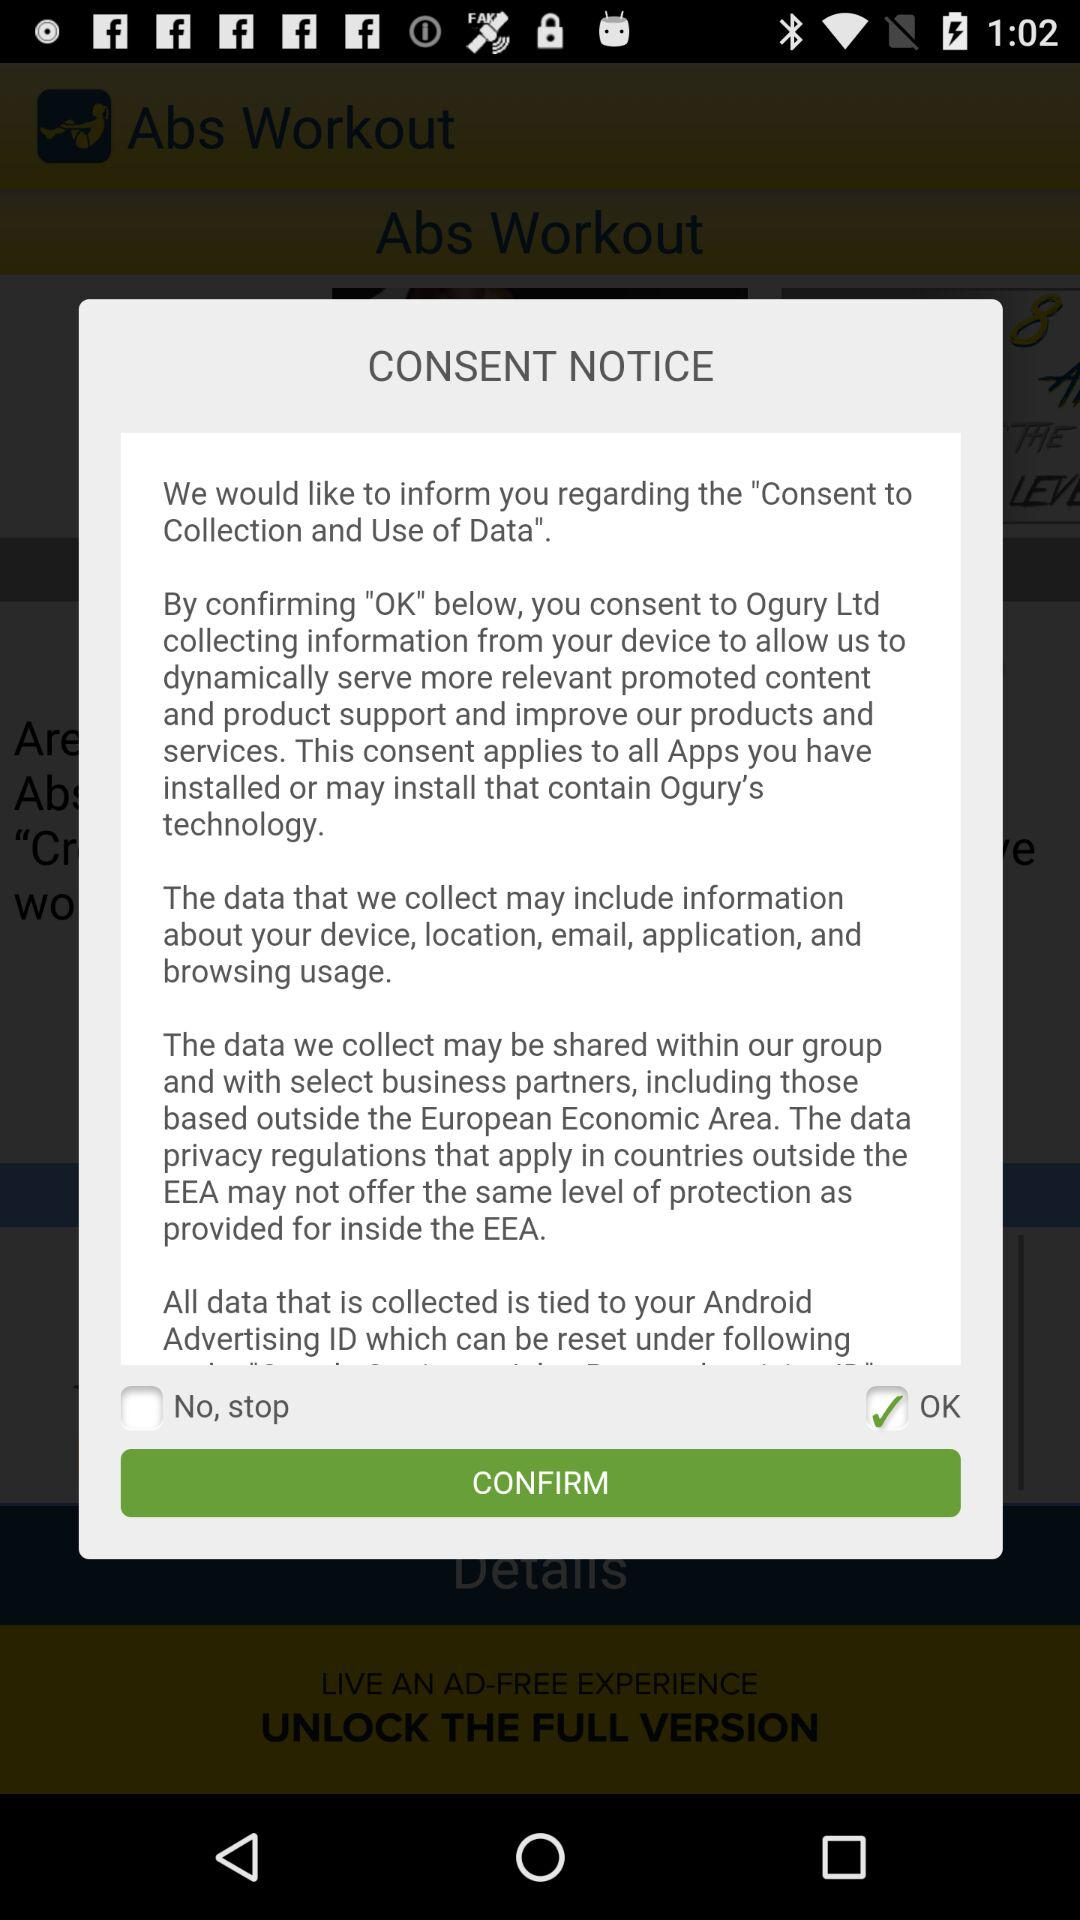What is the current status of the "OK"? The current status is "on". 